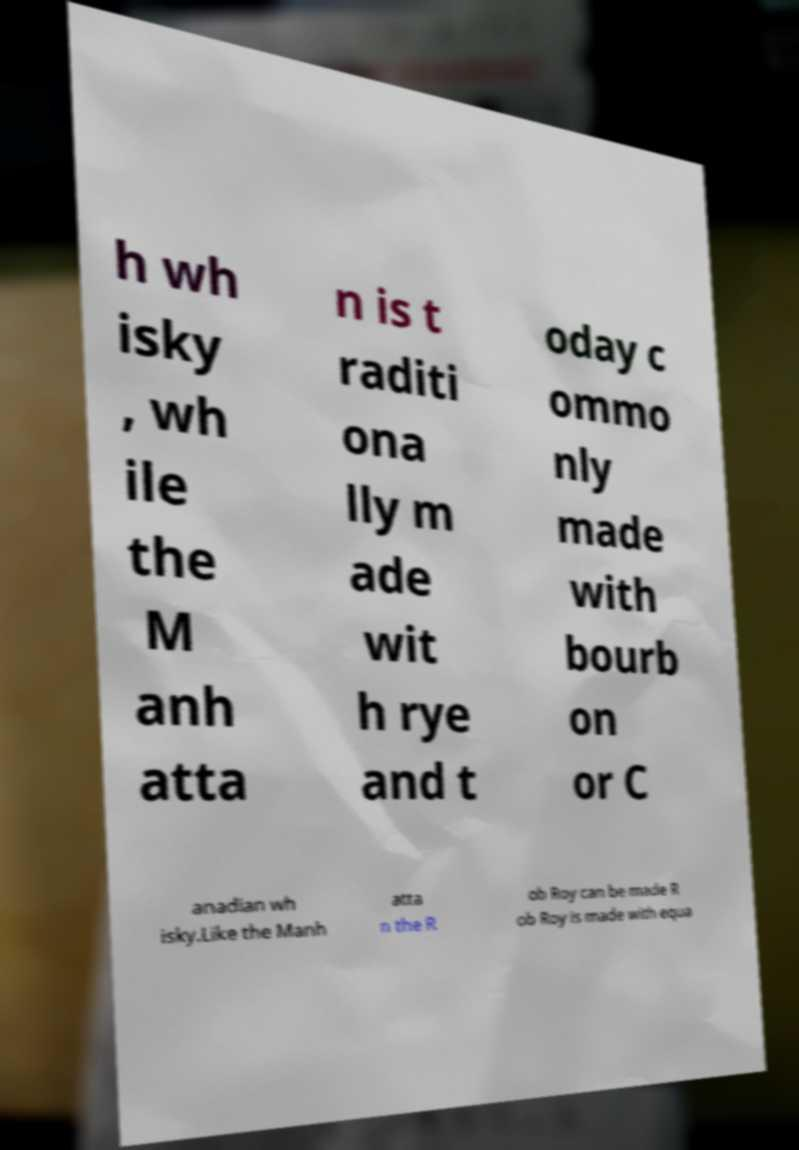What messages or text are displayed in this image? I need them in a readable, typed format. h wh isky , wh ile the M anh atta n is t raditi ona lly m ade wit h rye and t oday c ommo nly made with bourb on or C anadian wh isky.Like the Manh atta n the R ob Roy can be made R ob Roy is made with equa 